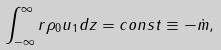<formula> <loc_0><loc_0><loc_500><loc_500>\int _ { - \infty } ^ { \infty } r \rho _ { 0 } u _ { 1 } d z = c o n s t \equiv - \dot { m } ,</formula> 